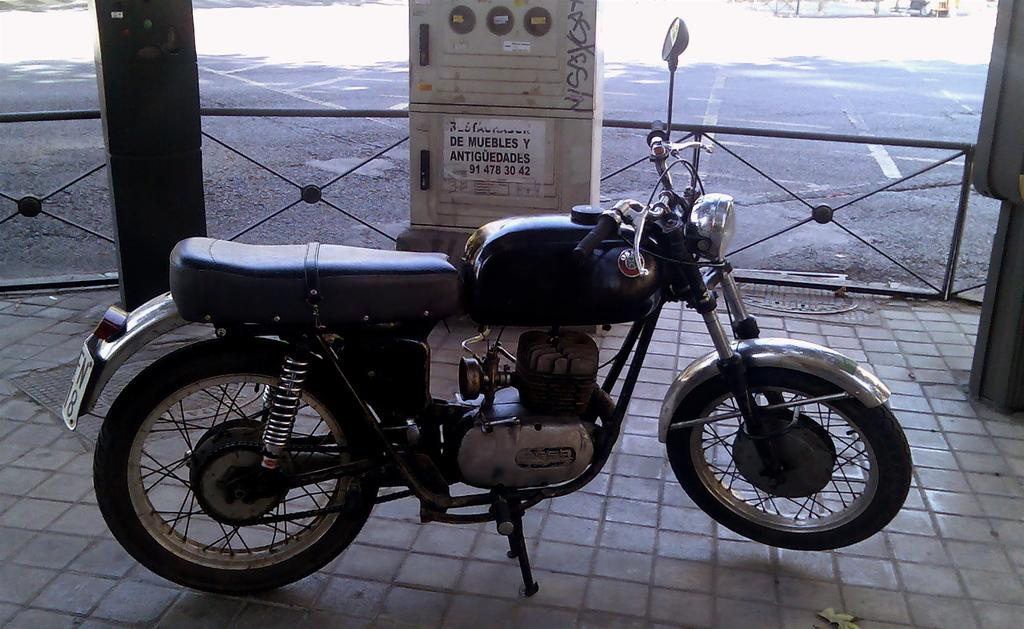What type of vehicle is in the image? There is a bullet bike in the image. What color is the bullet bike? The bullet bike is black in color. What can be seen in the background of the image? There is a road visible at the top of the image. How many circles can be seen on the bullet bike in the image? There are no circles visible on the bullet bike in the image. 